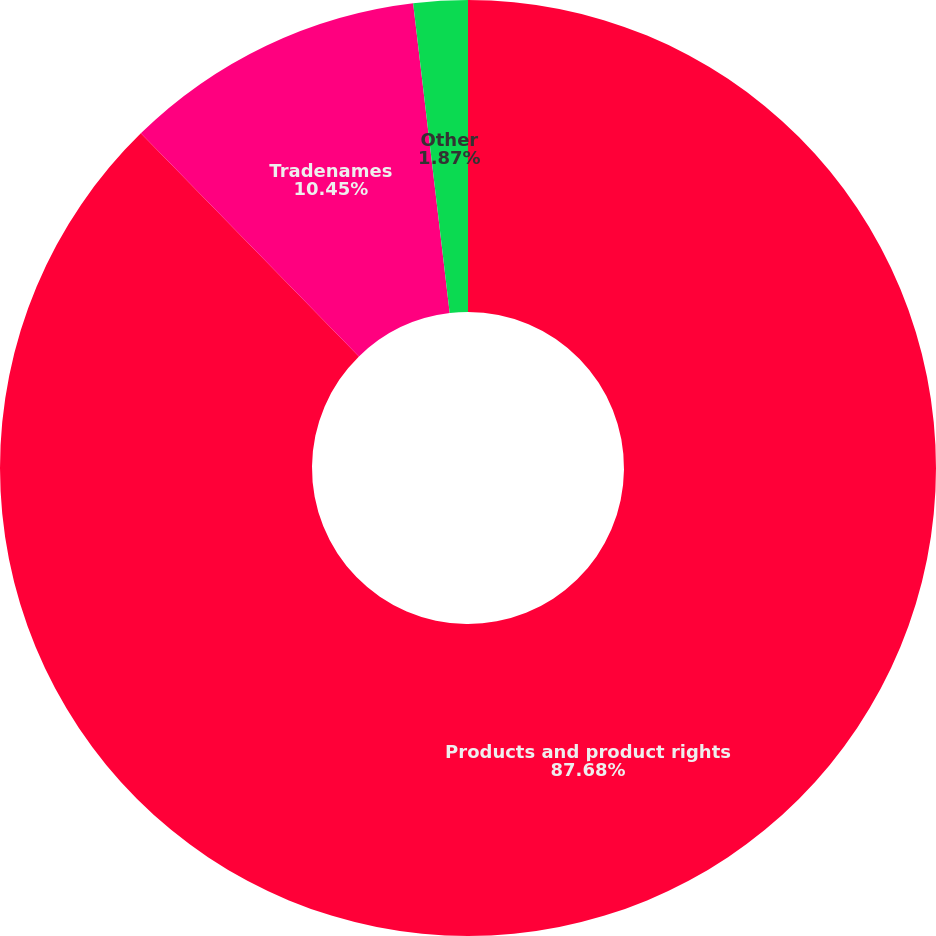Convert chart. <chart><loc_0><loc_0><loc_500><loc_500><pie_chart><fcel>Products and product rights<fcel>Tradenames<fcel>Other<nl><fcel>87.68%<fcel>10.45%<fcel>1.87%<nl></chart> 